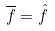<formula> <loc_0><loc_0><loc_500><loc_500>\overline { f } = \hat { f }</formula> 